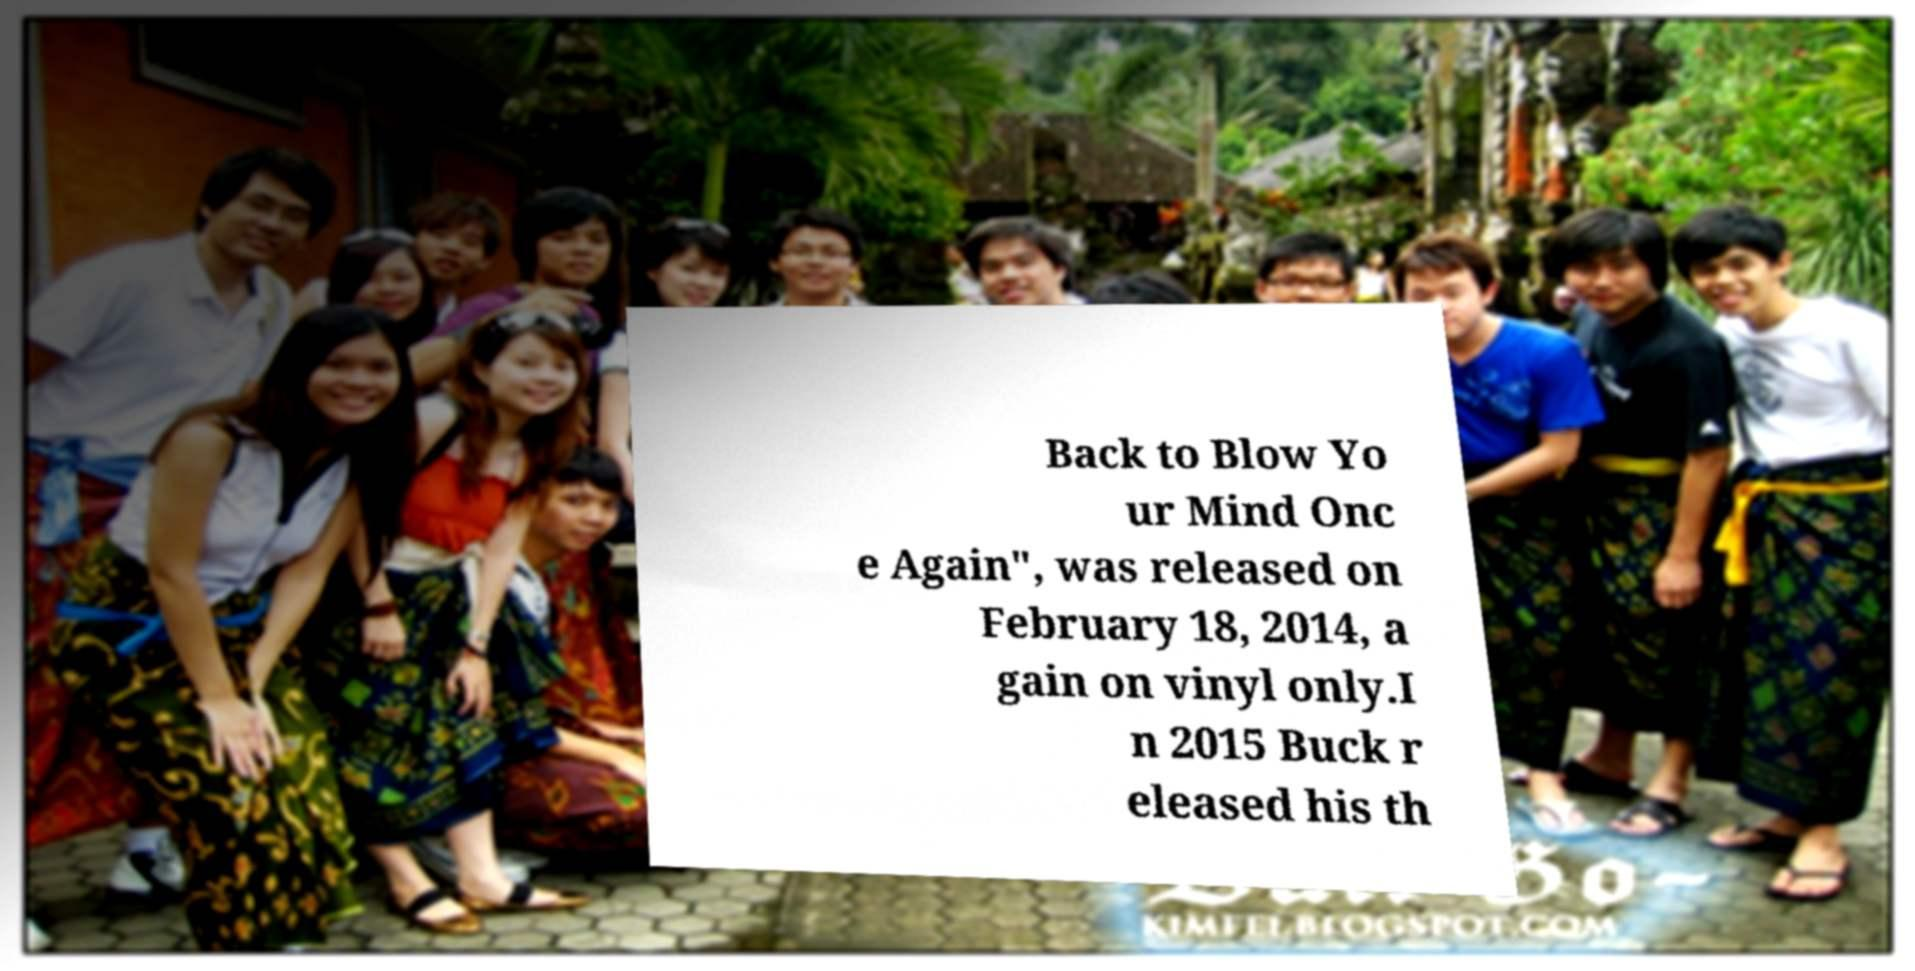Could you assist in decoding the text presented in this image and type it out clearly? Back to Blow Yo ur Mind Onc e Again", was released on February 18, 2014, a gain on vinyl only.I n 2015 Buck r eleased his th 